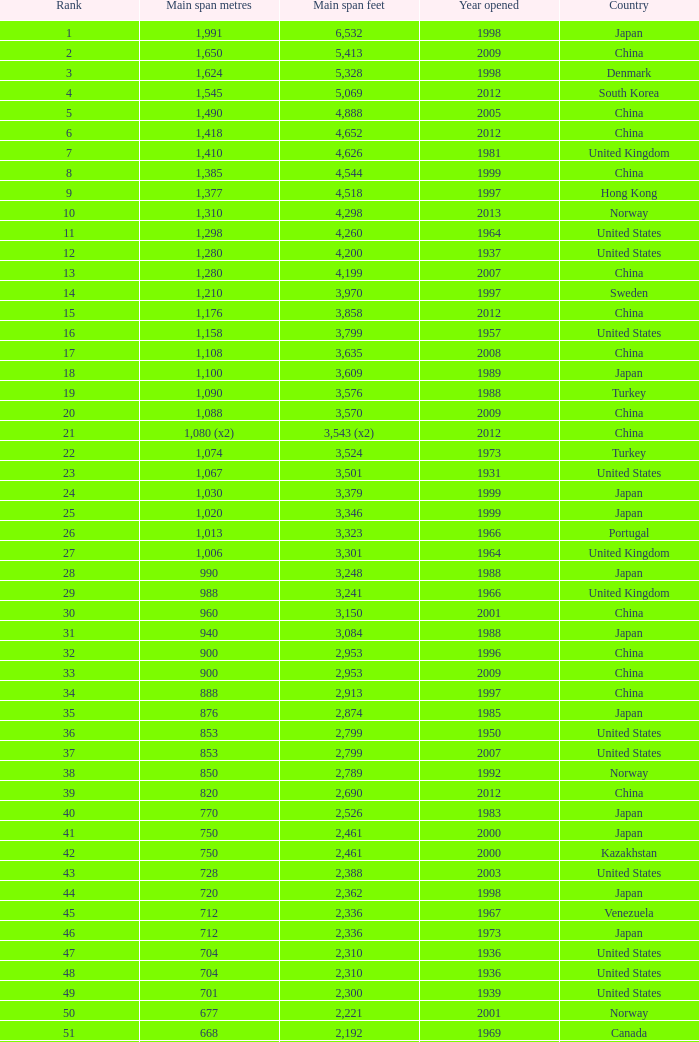What is the main span in feet from a year of 2009 or more recent with a rank less than 94 and 1,310 main span metres? 4298.0. 